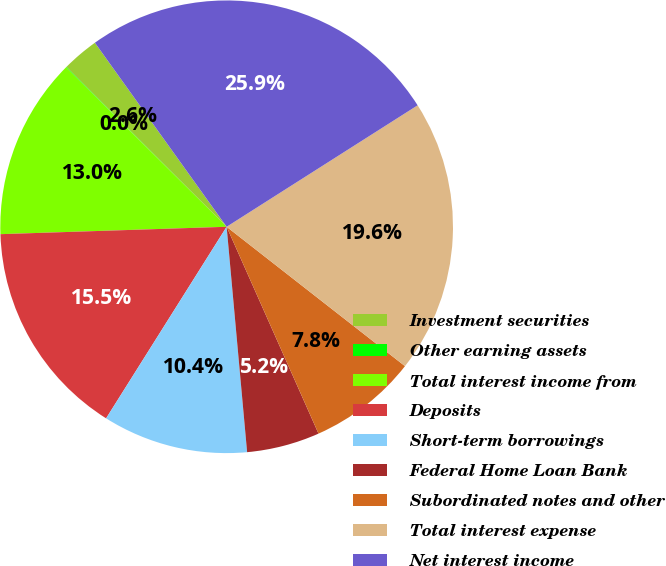Convert chart. <chart><loc_0><loc_0><loc_500><loc_500><pie_chart><fcel>Investment securities<fcel>Other earning assets<fcel>Total interest income from<fcel>Deposits<fcel>Short-term borrowings<fcel>Federal Home Loan Bank<fcel>Subordinated notes and other<fcel>Total interest expense<fcel>Net interest income<nl><fcel>2.63%<fcel>0.04%<fcel>12.96%<fcel>15.54%<fcel>10.38%<fcel>5.21%<fcel>7.79%<fcel>19.57%<fcel>25.87%<nl></chart> 